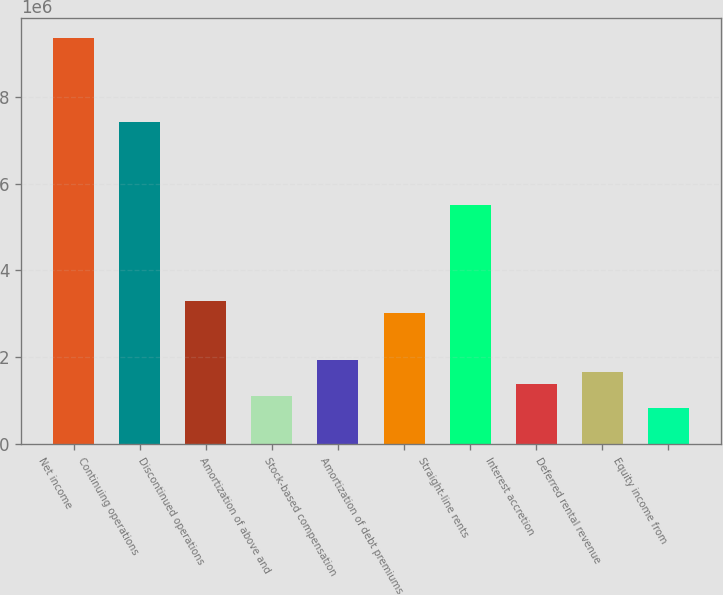<chart> <loc_0><loc_0><loc_500><loc_500><bar_chart><fcel>Net income<fcel>Continuing operations<fcel>Discontinued operations<fcel>Amortization of above and<fcel>Stock-based compensation<fcel>Amortization of debt premiums<fcel>Straight-line rents<fcel>Interest accretion<fcel>Deferred rental revenue<fcel>Equity income from<nl><fcel>9.34954e+06<fcel>7.42467e+06<fcel>3.29996e+06<fcel>1.10012e+06<fcel>1.92506e+06<fcel>3.02498e+06<fcel>5.49981e+06<fcel>1.3751e+06<fcel>1.65008e+06<fcel>825134<nl></chart> 